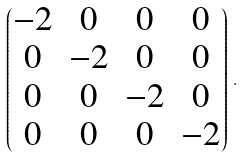Convert formula to latex. <formula><loc_0><loc_0><loc_500><loc_500>\begin{pmatrix} - 2 & 0 & 0 & 0 \\ 0 & - 2 & 0 & 0 \\ 0 & 0 & - 2 & 0 \\ 0 & 0 & 0 & - 2 \end{pmatrix} \, .</formula> 